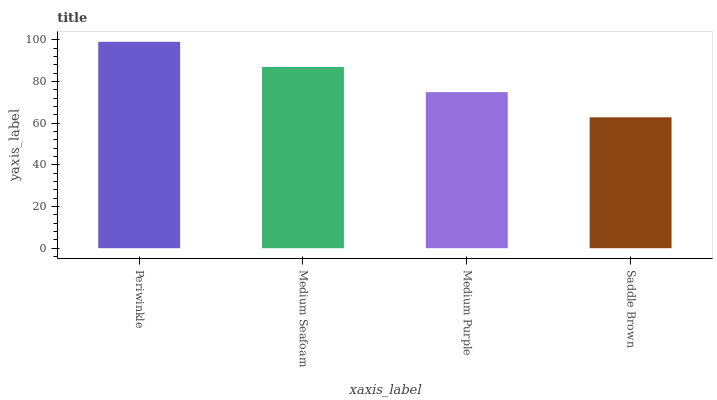Is Saddle Brown the minimum?
Answer yes or no. Yes. Is Periwinkle the maximum?
Answer yes or no. Yes. Is Medium Seafoam the minimum?
Answer yes or no. No. Is Medium Seafoam the maximum?
Answer yes or no. No. Is Periwinkle greater than Medium Seafoam?
Answer yes or no. Yes. Is Medium Seafoam less than Periwinkle?
Answer yes or no. Yes. Is Medium Seafoam greater than Periwinkle?
Answer yes or no. No. Is Periwinkle less than Medium Seafoam?
Answer yes or no. No. Is Medium Seafoam the high median?
Answer yes or no. Yes. Is Medium Purple the low median?
Answer yes or no. Yes. Is Saddle Brown the high median?
Answer yes or no. No. Is Medium Seafoam the low median?
Answer yes or no. No. 